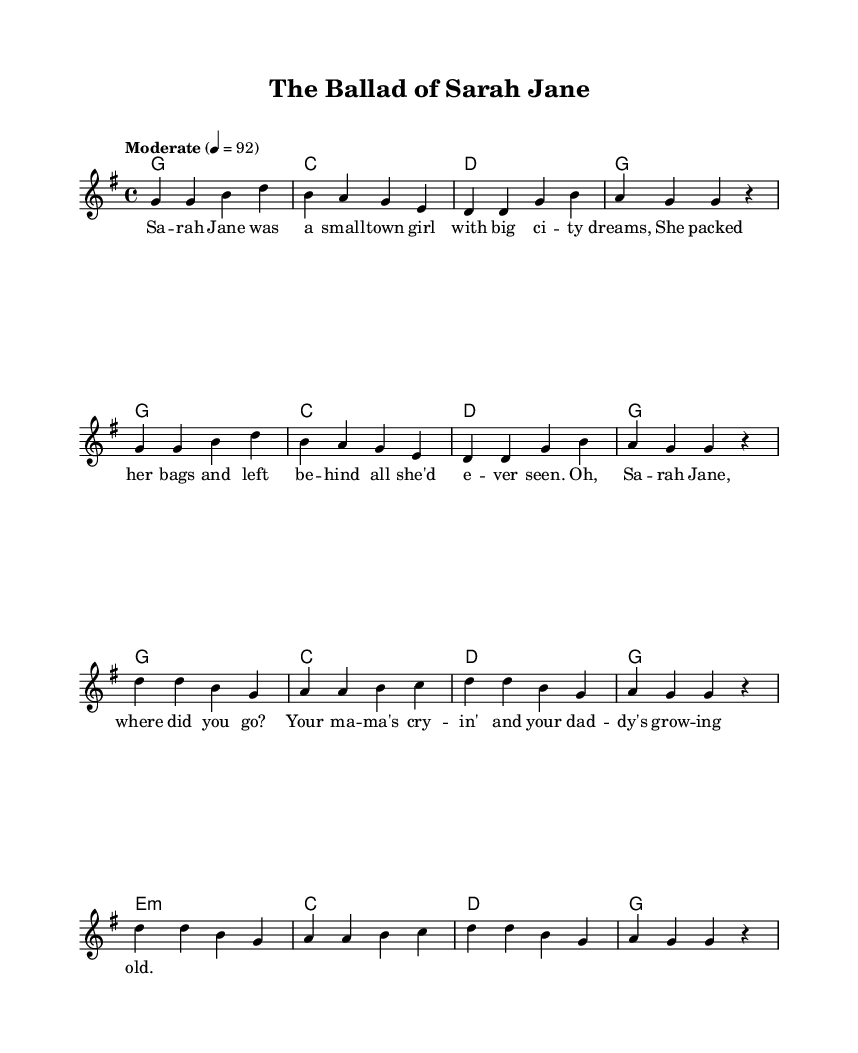What is the key signature of this music? The key signature can be found in the beginning of the music sheet, which indicates that it is in G major, as there is one sharp (F#) shown on the staff.
Answer: G major What is the time signature of this music? The time signature is displayed at the beginning of the sheet music, where it shows 4 over 4, indicating that there are four beats per measure.
Answer: 4/4 What is the tempo marking of the piece? The tempo marking is noted in the header section of the sheet music, which shows "Moderate" with a metronome marking of 92 beats per minute.
Answer: Moderate, 92 How many measures are in the verse section? By counting the measures in the specified verse portion in the melody and harmonies, we find that there are eight measures total.
Answer: Eight What type of musical form does this song follow? The structure can be discerned from the layout of the melody and lyrics, showing a typical verse-chorus form where the verse is followed by the chorus.
Answer: Verse-Chorus Which character is prominently mentioned in the lyrics? By examining the lyrics closely, it becomes clear that "Sarah Jane" is the main character featured throughout the song's narrative.
Answer: Sarah Jane What emotion does the narrative of the song evoke? The storytelling provided in the lyrics hints at feelings of nostalgia and sadness related to the character's journey, primarily seen in phrases about leaving home and familial distress.
Answer: Nostalgia 